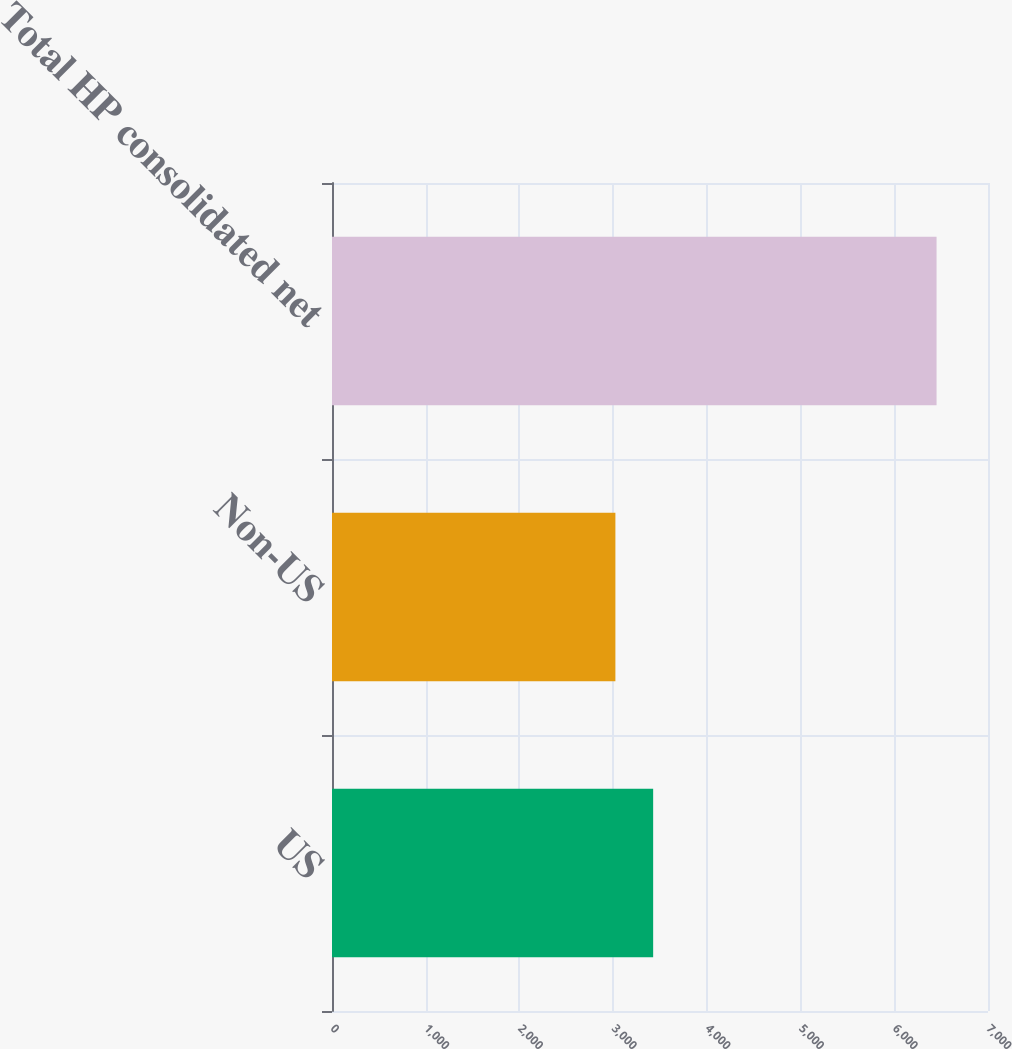Convert chart to OTSL. <chart><loc_0><loc_0><loc_500><loc_500><bar_chart><fcel>US<fcel>Non-US<fcel>Total HP consolidated net<nl><fcel>3427<fcel>3024<fcel>6451<nl></chart> 